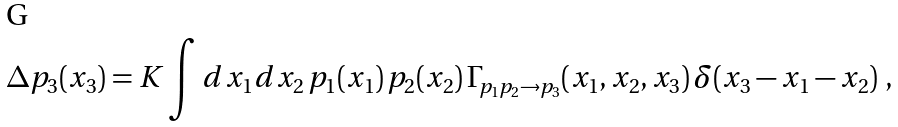<formula> <loc_0><loc_0><loc_500><loc_500>\Delta p _ { 3 } ( x _ { 3 } ) = K \int d x _ { 1 } d x _ { 2 } \, p _ { 1 } ( x _ { 1 } ) \, p _ { 2 } ( x _ { 2 } ) \, \Gamma _ { p _ { 1 } p _ { 2 } \rightarrow p _ { 3 } } ( x _ { 1 } , x _ { 2 } , x _ { 3 } ) \, \delta ( x _ { 3 } - x _ { 1 } - x _ { 2 } ) \ ,</formula> 